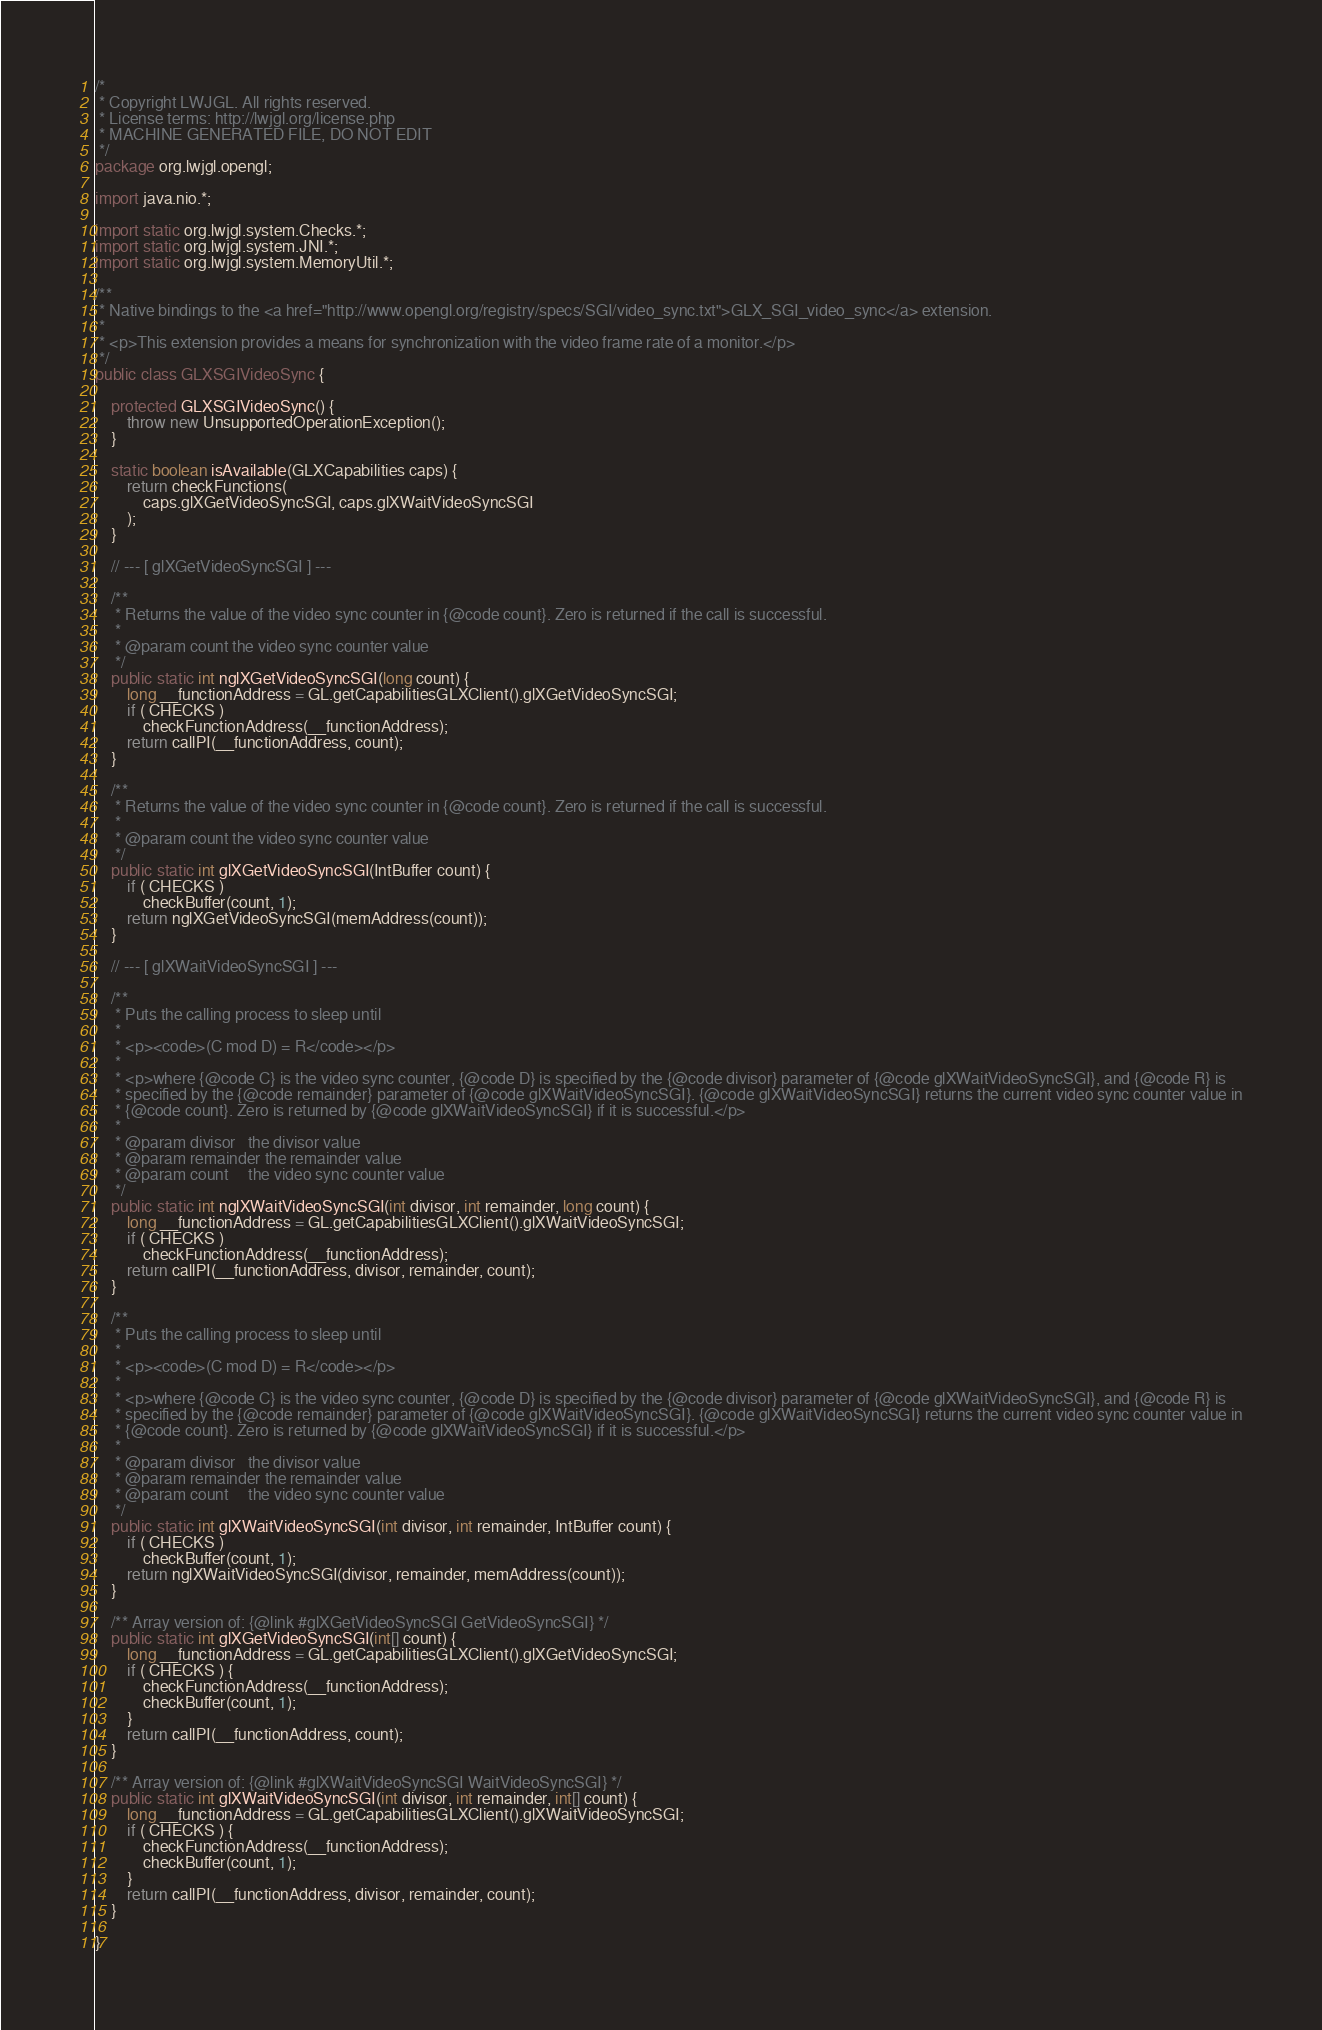<code> <loc_0><loc_0><loc_500><loc_500><_Java_>/*
 * Copyright LWJGL. All rights reserved.
 * License terms: http://lwjgl.org/license.php
 * MACHINE GENERATED FILE, DO NOT EDIT
 */
package org.lwjgl.opengl;

import java.nio.*;

import static org.lwjgl.system.Checks.*;
import static org.lwjgl.system.JNI.*;
import static org.lwjgl.system.MemoryUtil.*;

/**
 * Native bindings to the <a href="http://www.opengl.org/registry/specs/SGI/video_sync.txt">GLX_SGI_video_sync</a> extension.
 * 
 * <p>This extension provides a means for synchronization with the video frame rate of a monitor.</p>
 */
public class GLXSGIVideoSync {

	protected GLXSGIVideoSync() {
		throw new UnsupportedOperationException();
	}

	static boolean isAvailable(GLXCapabilities caps) {
		return checkFunctions(
			caps.glXGetVideoSyncSGI, caps.glXWaitVideoSyncSGI
		);
	}

	// --- [ glXGetVideoSyncSGI ] ---

	/**
	 * Returns the value of the video sync counter in {@code count}. Zero is returned if the call is successful.
	 *
	 * @param count the video sync counter value
	 */
	public static int nglXGetVideoSyncSGI(long count) {
		long __functionAddress = GL.getCapabilitiesGLXClient().glXGetVideoSyncSGI;
		if ( CHECKS )
			checkFunctionAddress(__functionAddress);
		return callPI(__functionAddress, count);
	}

	/**
	 * Returns the value of the video sync counter in {@code count}. Zero is returned if the call is successful.
	 *
	 * @param count the video sync counter value
	 */
	public static int glXGetVideoSyncSGI(IntBuffer count) {
		if ( CHECKS )
			checkBuffer(count, 1);
		return nglXGetVideoSyncSGI(memAddress(count));
	}

	// --- [ glXWaitVideoSyncSGI ] ---

	/**
	 * Puts the calling process to sleep until
	 * 
	 * <p><code>(C mod D) = R</code></p>
	 * 
	 * <p>where {@code C} is the video sync counter, {@code D} is specified by the {@code divisor} parameter of {@code glXWaitVideoSyncSGI}, and {@code R} is
	 * specified by the {@code remainder} parameter of {@code glXWaitVideoSyncSGI}. {@code glXWaitVideoSyncSGI} returns the current video sync counter value in
	 * {@code count}. Zero is returned by {@code glXWaitVideoSyncSGI} if it is successful.</p>
	 *
	 * @param divisor   the divisor value
	 * @param remainder the remainder value
	 * @param count     the video sync counter value
	 */
	public static int nglXWaitVideoSyncSGI(int divisor, int remainder, long count) {
		long __functionAddress = GL.getCapabilitiesGLXClient().glXWaitVideoSyncSGI;
		if ( CHECKS )
			checkFunctionAddress(__functionAddress);
		return callPI(__functionAddress, divisor, remainder, count);
	}

	/**
	 * Puts the calling process to sleep until
	 * 
	 * <p><code>(C mod D) = R</code></p>
	 * 
	 * <p>where {@code C} is the video sync counter, {@code D} is specified by the {@code divisor} parameter of {@code glXWaitVideoSyncSGI}, and {@code R} is
	 * specified by the {@code remainder} parameter of {@code glXWaitVideoSyncSGI}. {@code glXWaitVideoSyncSGI} returns the current video sync counter value in
	 * {@code count}. Zero is returned by {@code glXWaitVideoSyncSGI} if it is successful.</p>
	 *
	 * @param divisor   the divisor value
	 * @param remainder the remainder value
	 * @param count     the video sync counter value
	 */
	public static int glXWaitVideoSyncSGI(int divisor, int remainder, IntBuffer count) {
		if ( CHECKS )
			checkBuffer(count, 1);
		return nglXWaitVideoSyncSGI(divisor, remainder, memAddress(count));
	}

	/** Array version of: {@link #glXGetVideoSyncSGI GetVideoSyncSGI} */
	public static int glXGetVideoSyncSGI(int[] count) {
		long __functionAddress = GL.getCapabilitiesGLXClient().glXGetVideoSyncSGI;
		if ( CHECKS ) {
			checkFunctionAddress(__functionAddress);
			checkBuffer(count, 1);
		}
		return callPI(__functionAddress, count);
	}

	/** Array version of: {@link #glXWaitVideoSyncSGI WaitVideoSyncSGI} */
	public static int glXWaitVideoSyncSGI(int divisor, int remainder, int[] count) {
		long __functionAddress = GL.getCapabilitiesGLXClient().glXWaitVideoSyncSGI;
		if ( CHECKS ) {
			checkFunctionAddress(__functionAddress);
			checkBuffer(count, 1);
		}
		return callPI(__functionAddress, divisor, remainder, count);
	}

}</code> 